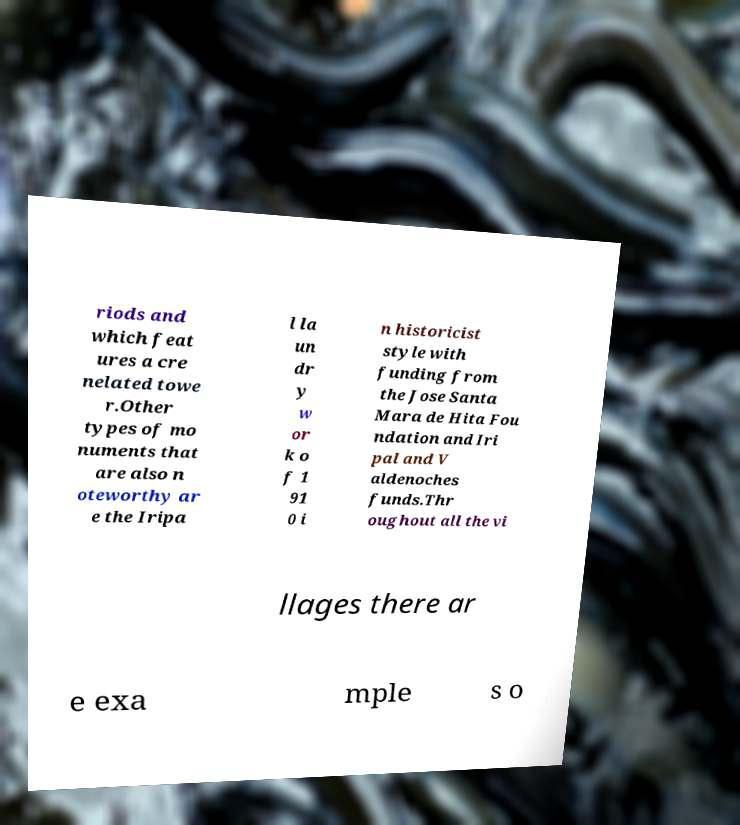There's text embedded in this image that I need extracted. Can you transcribe it verbatim? riods and which feat ures a cre nelated towe r.Other types of mo numents that are also n oteworthy ar e the Iripa l la un dr y w or k o f 1 91 0 i n historicist style with funding from the Jose Santa Mara de Hita Fou ndation and Iri pal and V aldenoches funds.Thr oughout all the vi llages there ar e exa mple s o 